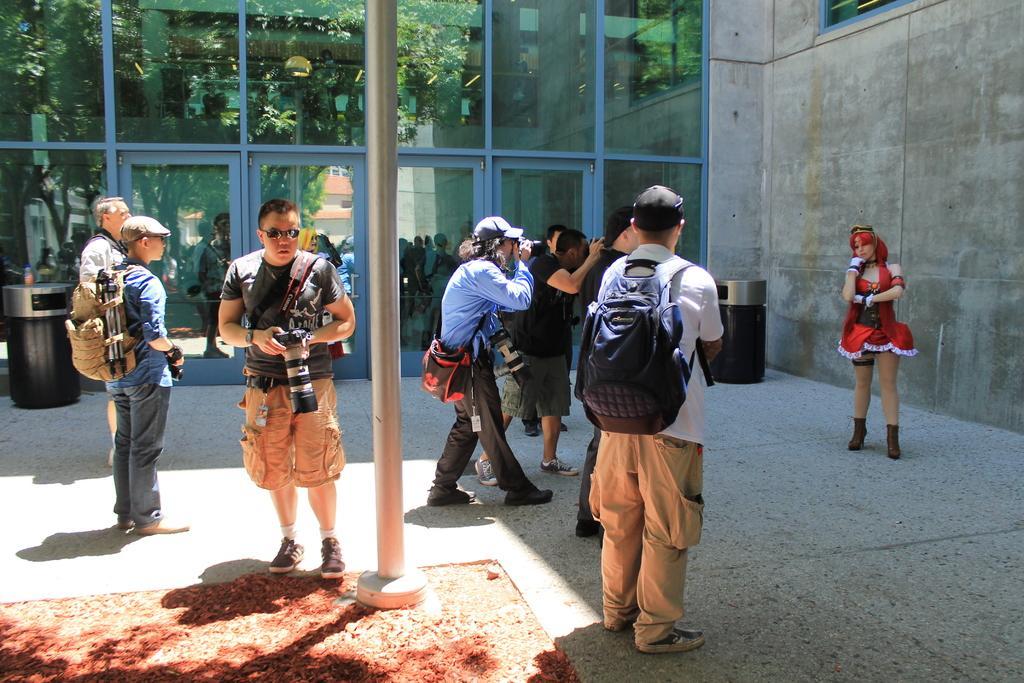How would you summarize this image in a sentence or two? In this picture we can observe some people standing on the land. Most of them are holding cameras in their hands. On the right side we can observe a woman standing, wearing red color dress. We can observe a pole. In the background there is a building. We can observe black color trash bins. 